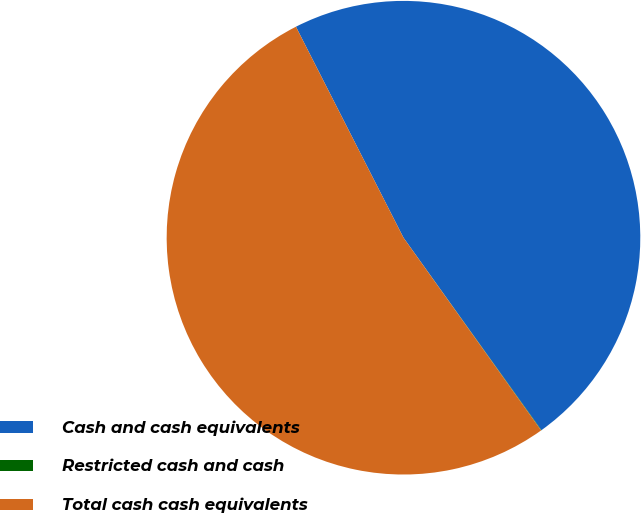Convert chart to OTSL. <chart><loc_0><loc_0><loc_500><loc_500><pie_chart><fcel>Cash and cash equivalents<fcel>Restricted cash and cash<fcel>Total cash cash equivalents<nl><fcel>47.61%<fcel>0.03%<fcel>52.37%<nl></chart> 